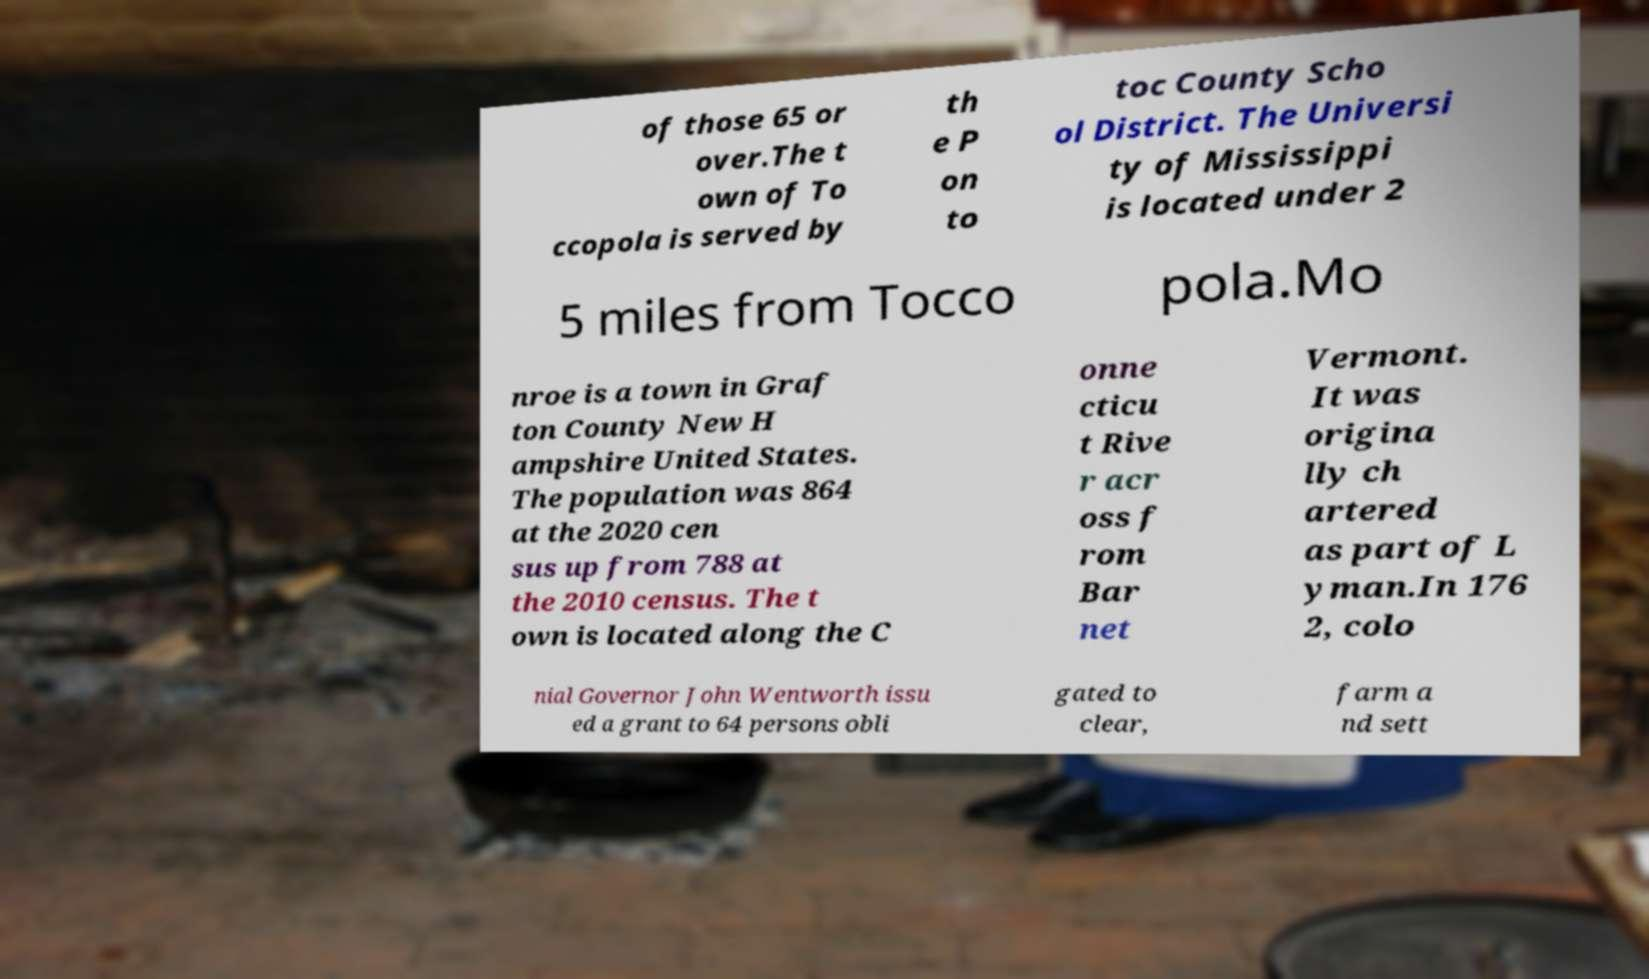Can you read and provide the text displayed in the image?This photo seems to have some interesting text. Can you extract and type it out for me? of those 65 or over.The t own of To ccopola is served by th e P on to toc County Scho ol District. The Universi ty of Mississippi is located under 2 5 miles from Tocco pola.Mo nroe is a town in Graf ton County New H ampshire United States. The population was 864 at the 2020 cen sus up from 788 at the 2010 census. The t own is located along the C onne cticu t Rive r acr oss f rom Bar net Vermont. It was origina lly ch artered as part of L yman.In 176 2, colo nial Governor John Wentworth issu ed a grant to 64 persons obli gated to clear, farm a nd sett 